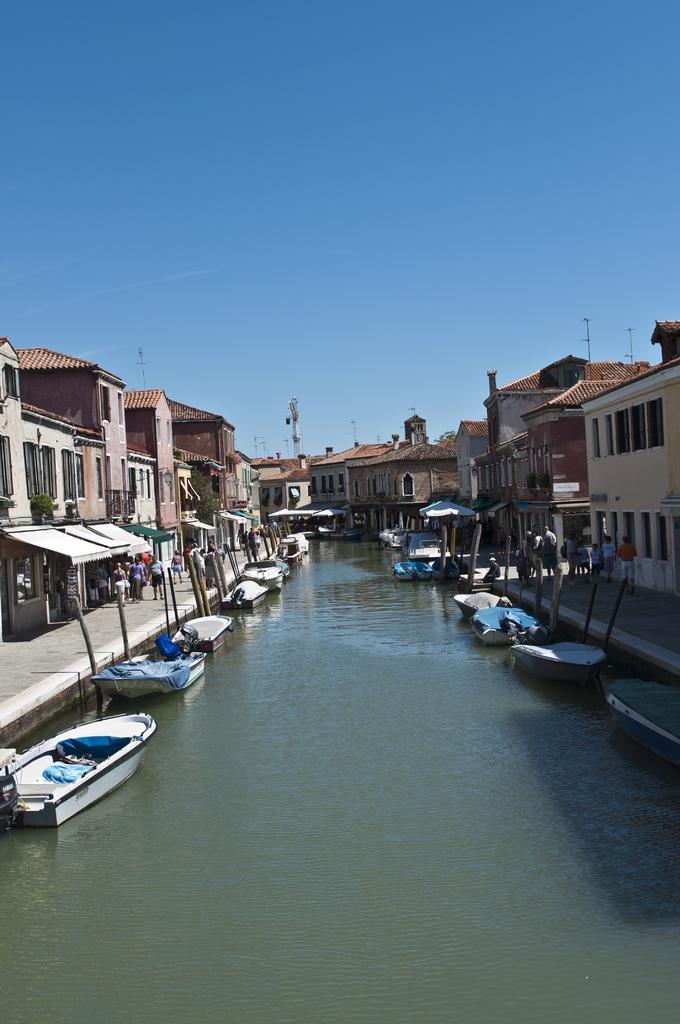How would you summarize this image in a sentence or two? In this picture we can see boats on water, beside the water we can see people on the ground and in the background we can see buildings, poles, sky. 